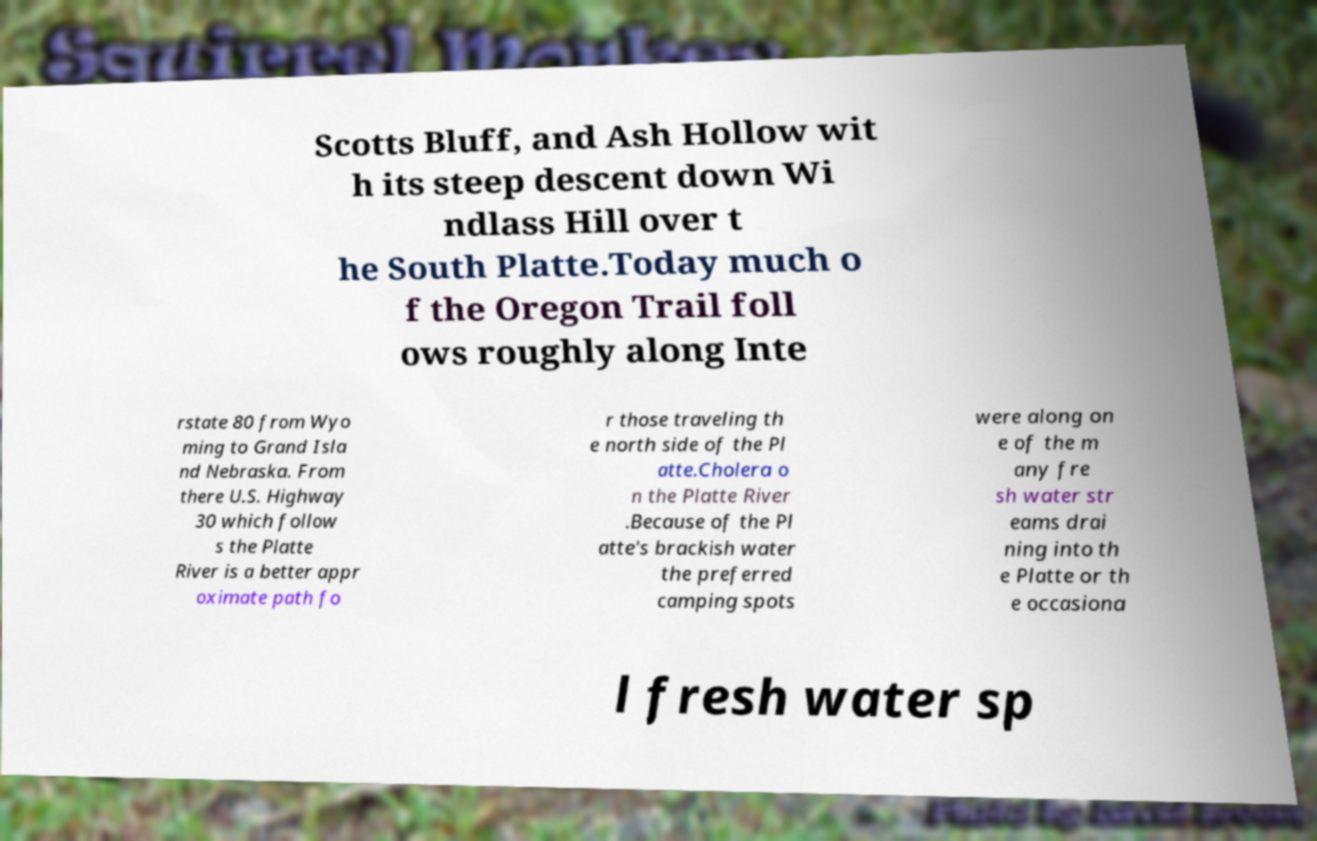I need the written content from this picture converted into text. Can you do that? Scotts Bluff, and Ash Hollow wit h its steep descent down Wi ndlass Hill over t he South Platte.Today much o f the Oregon Trail foll ows roughly along Inte rstate 80 from Wyo ming to Grand Isla nd Nebraska. From there U.S. Highway 30 which follow s the Platte River is a better appr oximate path fo r those traveling th e north side of the Pl atte.Cholera o n the Platte River .Because of the Pl atte's brackish water the preferred camping spots were along on e of the m any fre sh water str eams drai ning into th e Platte or th e occasiona l fresh water sp 